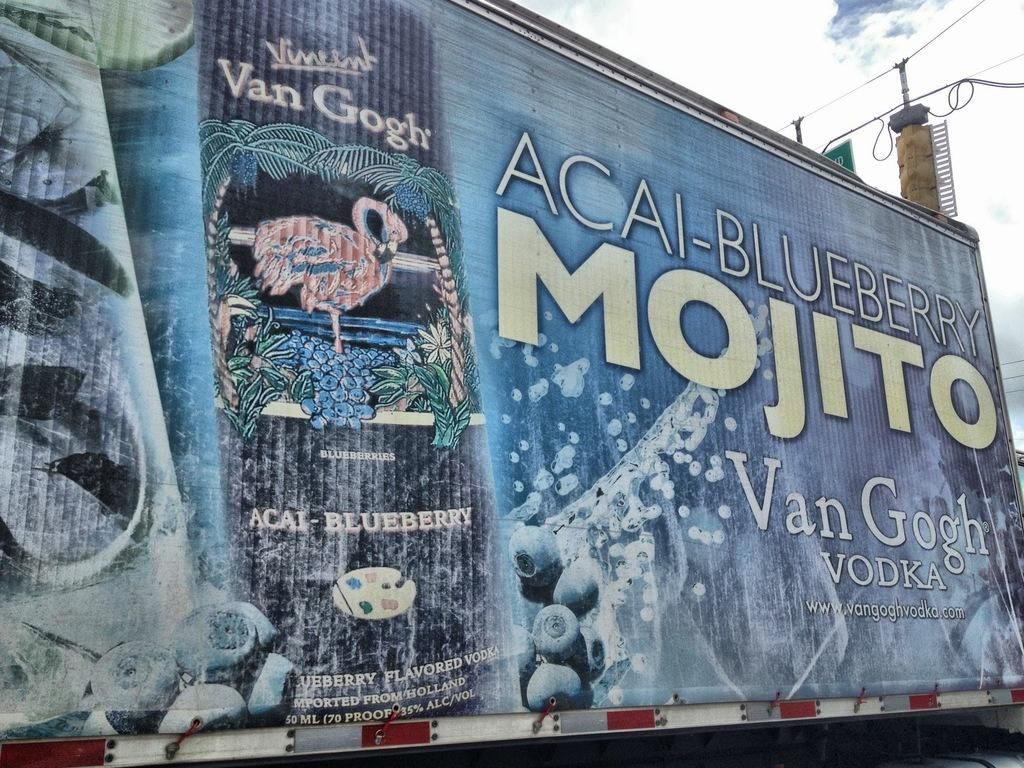<image>
Summarize the visual content of the image. The truck is painted with Van Gogh Vodka ads. 